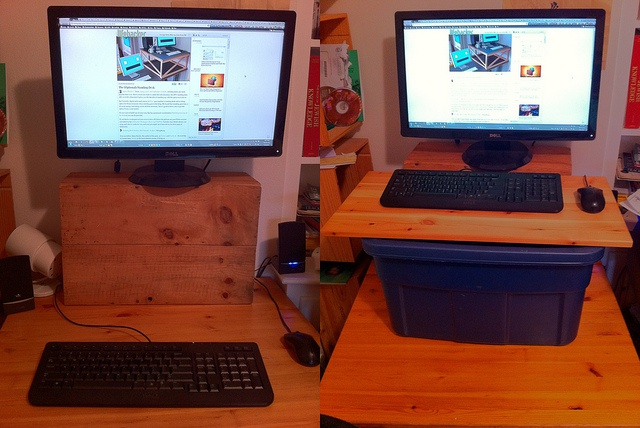Describe the objects in this image and their specific colors. I can see tv in brown, lightblue, black, and salmon tones, tv in brown, ivory, black, and lightblue tones, keyboard in brown, black, and maroon tones, keyboard in brown, black, and maroon tones, and book in brown and maroon tones in this image. 